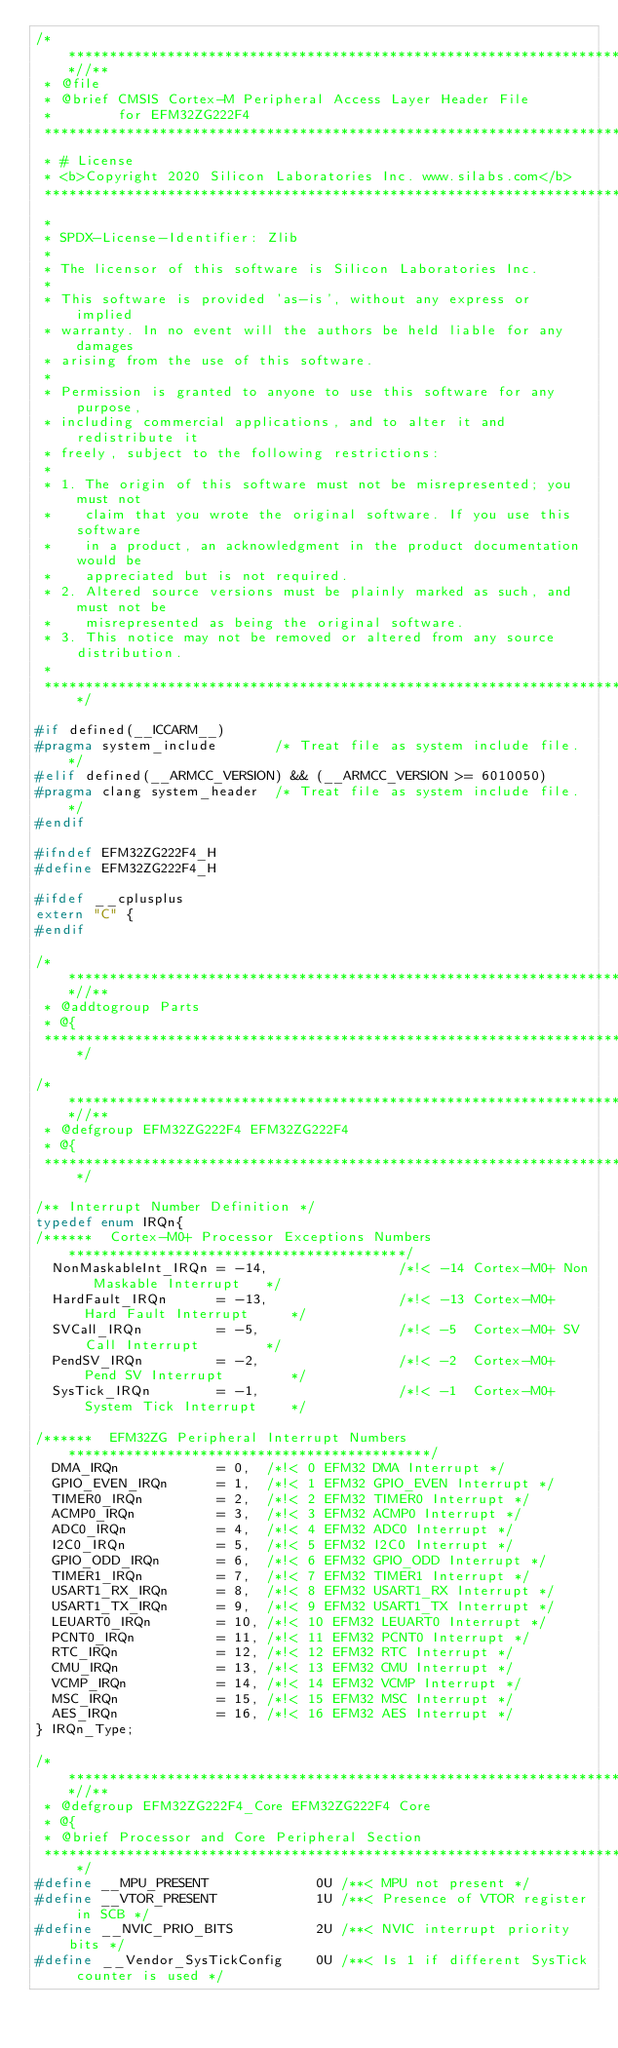<code> <loc_0><loc_0><loc_500><loc_500><_C_>/***************************************************************************//**
 * @file
 * @brief CMSIS Cortex-M Peripheral Access Layer Header File
 *        for EFM32ZG222F4
 *******************************************************************************
 * # License
 * <b>Copyright 2020 Silicon Laboratories Inc. www.silabs.com</b>
 *******************************************************************************
 *
 * SPDX-License-Identifier: Zlib
 *
 * The licensor of this software is Silicon Laboratories Inc.
 *
 * This software is provided 'as-is', without any express or implied
 * warranty. In no event will the authors be held liable for any damages
 * arising from the use of this software.
 *
 * Permission is granted to anyone to use this software for any purpose,
 * including commercial applications, and to alter it and redistribute it
 * freely, subject to the following restrictions:
 *
 * 1. The origin of this software must not be misrepresented; you must not
 *    claim that you wrote the original software. If you use this software
 *    in a product, an acknowledgment in the product documentation would be
 *    appreciated but is not required.
 * 2. Altered source versions must be plainly marked as such, and must not be
 *    misrepresented as being the original software.
 * 3. This notice may not be removed or altered from any source distribution.
 *
 ******************************************************************************/

#if defined(__ICCARM__)
#pragma system_include       /* Treat file as system include file. */
#elif defined(__ARMCC_VERSION) && (__ARMCC_VERSION >= 6010050)
#pragma clang system_header  /* Treat file as system include file. */
#endif

#ifndef EFM32ZG222F4_H
#define EFM32ZG222F4_H

#ifdef __cplusplus
extern "C" {
#endif

/***************************************************************************//**
 * @addtogroup Parts
 * @{
 ******************************************************************************/

/***************************************************************************//**
 * @defgroup EFM32ZG222F4 EFM32ZG222F4
 * @{
 ******************************************************************************/

/** Interrupt Number Definition */
typedef enum IRQn{
/******  Cortex-M0+ Processor Exceptions Numbers *****************************************/
  NonMaskableInt_IRQn = -14,                /*!< -14 Cortex-M0+ Non Maskable Interrupt   */
  HardFault_IRQn      = -13,                /*!< -13 Cortex-M0+ Hard Fault Interrupt     */
  SVCall_IRQn         = -5,                 /*!< -5  Cortex-M0+ SV Call Interrupt        */
  PendSV_IRQn         = -2,                 /*!< -2  Cortex-M0+ Pend SV Interrupt        */
  SysTick_IRQn        = -1,                 /*!< -1  Cortex-M0+ System Tick Interrupt    */

/******  EFM32ZG Peripheral Interrupt Numbers ********************************************/
  DMA_IRQn            = 0,  /*!< 0 EFM32 DMA Interrupt */
  GPIO_EVEN_IRQn      = 1,  /*!< 1 EFM32 GPIO_EVEN Interrupt */
  TIMER0_IRQn         = 2,  /*!< 2 EFM32 TIMER0 Interrupt */
  ACMP0_IRQn          = 3,  /*!< 3 EFM32 ACMP0 Interrupt */
  ADC0_IRQn           = 4,  /*!< 4 EFM32 ADC0 Interrupt */
  I2C0_IRQn           = 5,  /*!< 5 EFM32 I2C0 Interrupt */
  GPIO_ODD_IRQn       = 6,  /*!< 6 EFM32 GPIO_ODD Interrupt */
  TIMER1_IRQn         = 7,  /*!< 7 EFM32 TIMER1 Interrupt */
  USART1_RX_IRQn      = 8,  /*!< 8 EFM32 USART1_RX Interrupt */
  USART1_TX_IRQn      = 9,  /*!< 9 EFM32 USART1_TX Interrupt */
  LEUART0_IRQn        = 10, /*!< 10 EFM32 LEUART0 Interrupt */
  PCNT0_IRQn          = 11, /*!< 11 EFM32 PCNT0 Interrupt */
  RTC_IRQn            = 12, /*!< 12 EFM32 RTC Interrupt */
  CMU_IRQn            = 13, /*!< 13 EFM32 CMU Interrupt */
  VCMP_IRQn           = 14, /*!< 14 EFM32 VCMP Interrupt */
  MSC_IRQn            = 15, /*!< 15 EFM32 MSC Interrupt */
  AES_IRQn            = 16, /*!< 16 EFM32 AES Interrupt */
} IRQn_Type;

/***************************************************************************//**
 * @defgroup EFM32ZG222F4_Core EFM32ZG222F4 Core
 * @{
 * @brief Processor and Core Peripheral Section
 ******************************************************************************/
#define __MPU_PRESENT             0U /**< MPU not present */
#define __VTOR_PRESENT            1U /**< Presence of VTOR register in SCB */
#define __NVIC_PRIO_BITS          2U /**< NVIC interrupt priority bits */
#define __Vendor_SysTickConfig    0U /**< Is 1 if different SysTick counter is used */
</code> 